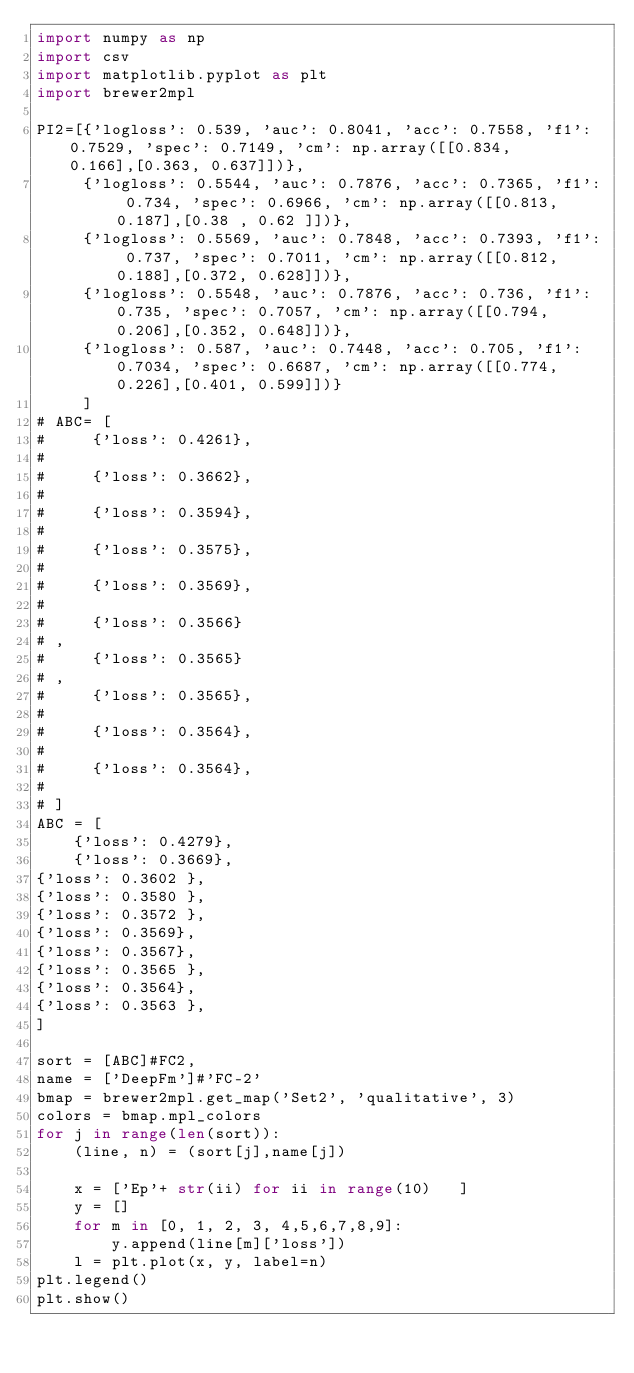<code> <loc_0><loc_0><loc_500><loc_500><_Python_>import numpy as np
import csv
import matplotlib.pyplot as plt
import brewer2mpl

PI2=[{'logloss': 0.539, 'auc': 0.8041, 'acc': 0.7558, 'f1': 0.7529, 'spec': 0.7149, 'cm': np.array([[0.834, 0.166],[0.363, 0.637]])},
     {'logloss': 0.5544, 'auc': 0.7876, 'acc': 0.7365, 'f1': 0.734, 'spec': 0.6966, 'cm': np.array([[0.813, 0.187],[0.38 , 0.62 ]])},
     {'logloss': 0.5569, 'auc': 0.7848, 'acc': 0.7393, 'f1': 0.737, 'spec': 0.7011, 'cm': np.array([[0.812, 0.188],[0.372, 0.628]])},
     {'logloss': 0.5548, 'auc': 0.7876, 'acc': 0.736, 'f1': 0.735, 'spec': 0.7057, 'cm': np.array([[0.794, 0.206],[0.352, 0.648]])},
     {'logloss': 0.587, 'auc': 0.7448, 'acc': 0.705, 'f1': 0.7034, 'spec': 0.6687, 'cm': np.array([[0.774, 0.226],[0.401, 0.599]])}
     ]
# ABC= [
#     {'loss': 0.4261},
#
#     {'loss': 0.3662},
#
#     {'loss': 0.3594},
#
#     {'loss': 0.3575},
#
#     {'loss': 0.3569},
#
#     {'loss': 0.3566}
# ,
#     {'loss': 0.3565}
# ,
#     {'loss': 0.3565},
#
#     {'loss': 0.3564},
#
#     {'loss': 0.3564},
#
# ]
ABC = [
    {'loss': 0.4279},
    {'loss': 0.3669},
{'loss': 0.3602 },
{'loss': 0.3580 },
{'loss': 0.3572 },
{'loss': 0.3569},
{'loss': 0.3567},
{'loss': 0.3565 },
{'loss': 0.3564},
{'loss': 0.3563 },
]

sort = [ABC]#FC2,
name = ['DeepFm']#'FC-2'
bmap = brewer2mpl.get_map('Set2', 'qualitative', 3)
colors = bmap.mpl_colors
for j in range(len(sort)):
    (line, n) = (sort[j],name[j])

    x = ['Ep'+ str(ii) for ii in range(10)   ]
    y = []
    for m in [0, 1, 2, 3, 4,5,6,7,8,9]:
        y.append(line[m]['loss'])
    l = plt.plot(x, y, label=n)
plt.legend()
plt.show()</code> 